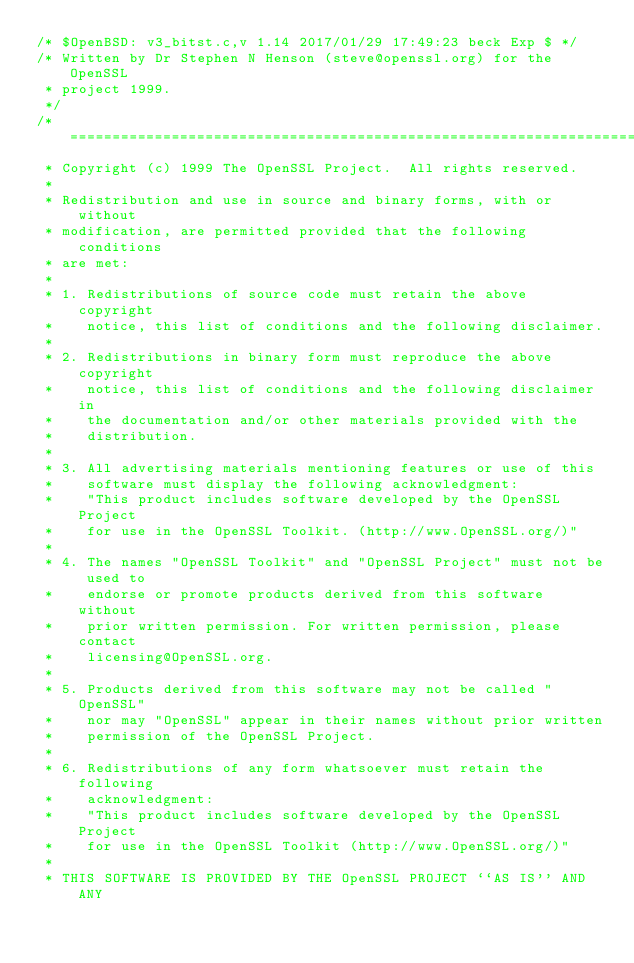<code> <loc_0><loc_0><loc_500><loc_500><_C_>/* $OpenBSD: v3_bitst.c,v 1.14 2017/01/29 17:49:23 beck Exp $ */
/* Written by Dr Stephen N Henson (steve@openssl.org) for the OpenSSL
 * project 1999.
 */
/* ====================================================================
 * Copyright (c) 1999 The OpenSSL Project.  All rights reserved.
 *
 * Redistribution and use in source and binary forms, with or without
 * modification, are permitted provided that the following conditions
 * are met:
 *
 * 1. Redistributions of source code must retain the above copyright
 *    notice, this list of conditions and the following disclaimer.
 *
 * 2. Redistributions in binary form must reproduce the above copyright
 *    notice, this list of conditions and the following disclaimer in
 *    the documentation and/or other materials provided with the
 *    distribution.
 *
 * 3. All advertising materials mentioning features or use of this
 *    software must display the following acknowledgment:
 *    "This product includes software developed by the OpenSSL Project
 *    for use in the OpenSSL Toolkit. (http://www.OpenSSL.org/)"
 *
 * 4. The names "OpenSSL Toolkit" and "OpenSSL Project" must not be used to
 *    endorse or promote products derived from this software without
 *    prior written permission. For written permission, please contact
 *    licensing@OpenSSL.org.
 *
 * 5. Products derived from this software may not be called "OpenSSL"
 *    nor may "OpenSSL" appear in their names without prior written
 *    permission of the OpenSSL Project.
 *
 * 6. Redistributions of any form whatsoever must retain the following
 *    acknowledgment:
 *    "This product includes software developed by the OpenSSL Project
 *    for use in the OpenSSL Toolkit (http://www.OpenSSL.org/)"
 *
 * THIS SOFTWARE IS PROVIDED BY THE OpenSSL PROJECT ``AS IS'' AND ANY</code> 